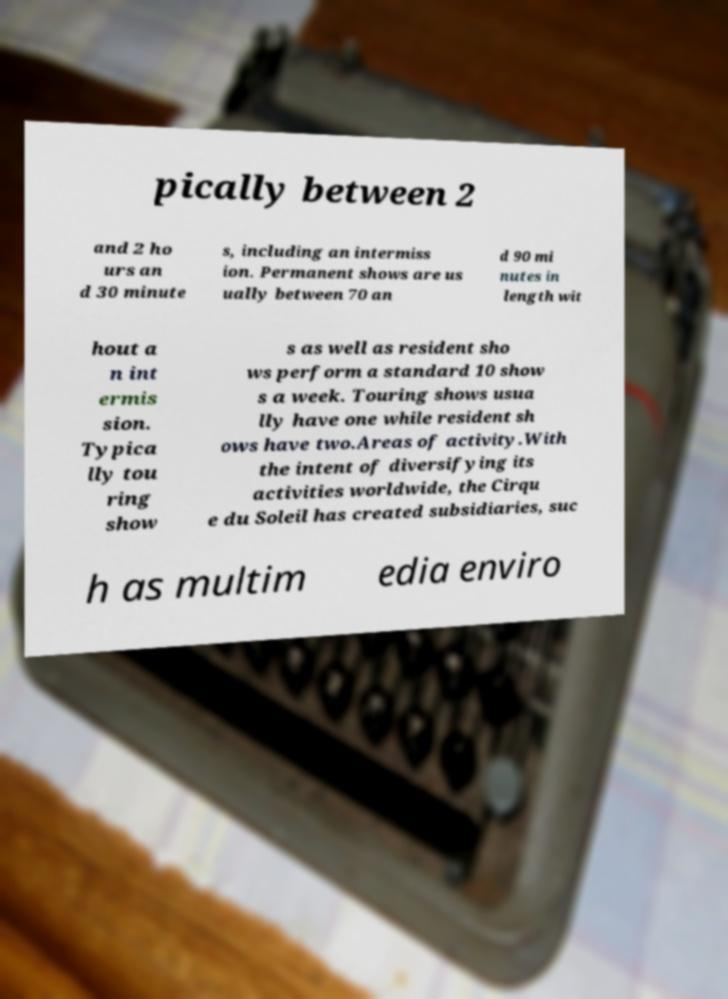Could you extract and type out the text from this image? pically between 2 and 2 ho urs an d 30 minute s, including an intermiss ion. Permanent shows are us ually between 70 an d 90 mi nutes in length wit hout a n int ermis sion. Typica lly tou ring show s as well as resident sho ws perform a standard 10 show s a week. Touring shows usua lly have one while resident sh ows have two.Areas of activity.With the intent of diversifying its activities worldwide, the Cirqu e du Soleil has created subsidiaries, suc h as multim edia enviro 